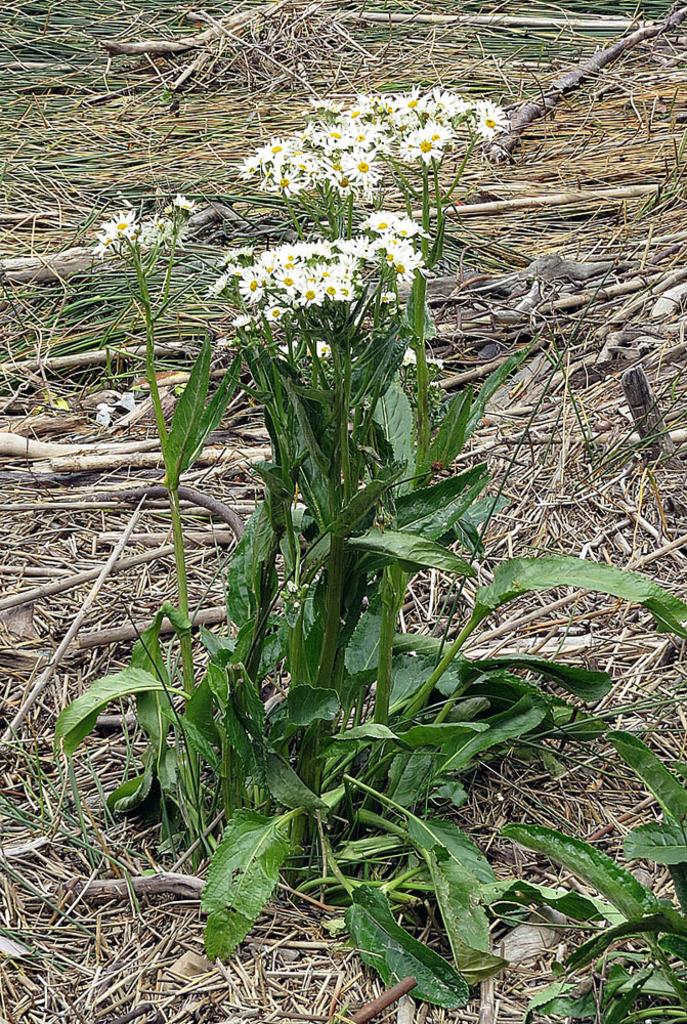What type of plant is in the image? There is a plant in the image, but the specific type is not mentioned. What color is the plant in the image? The plant is green. What other floral elements are present in the image? There are flowers in the image. What colors are the flowers? The flowers are white and yellow. What can be seen in the background of the image? The background of the image includes dried grass. What type of coach can be seen in the image? There is no coach present in the image; it features a plant, flowers, and dried grass in the background. What substance is being ploughed in the image? There is no plough or any indication of ploughing in the image. 